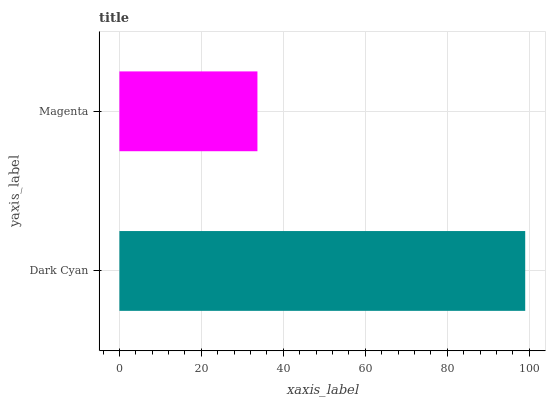Is Magenta the minimum?
Answer yes or no. Yes. Is Dark Cyan the maximum?
Answer yes or no. Yes. Is Magenta the maximum?
Answer yes or no. No. Is Dark Cyan greater than Magenta?
Answer yes or no. Yes. Is Magenta less than Dark Cyan?
Answer yes or no. Yes. Is Magenta greater than Dark Cyan?
Answer yes or no. No. Is Dark Cyan less than Magenta?
Answer yes or no. No. Is Dark Cyan the high median?
Answer yes or no. Yes. Is Magenta the low median?
Answer yes or no. Yes. Is Magenta the high median?
Answer yes or no. No. Is Dark Cyan the low median?
Answer yes or no. No. 